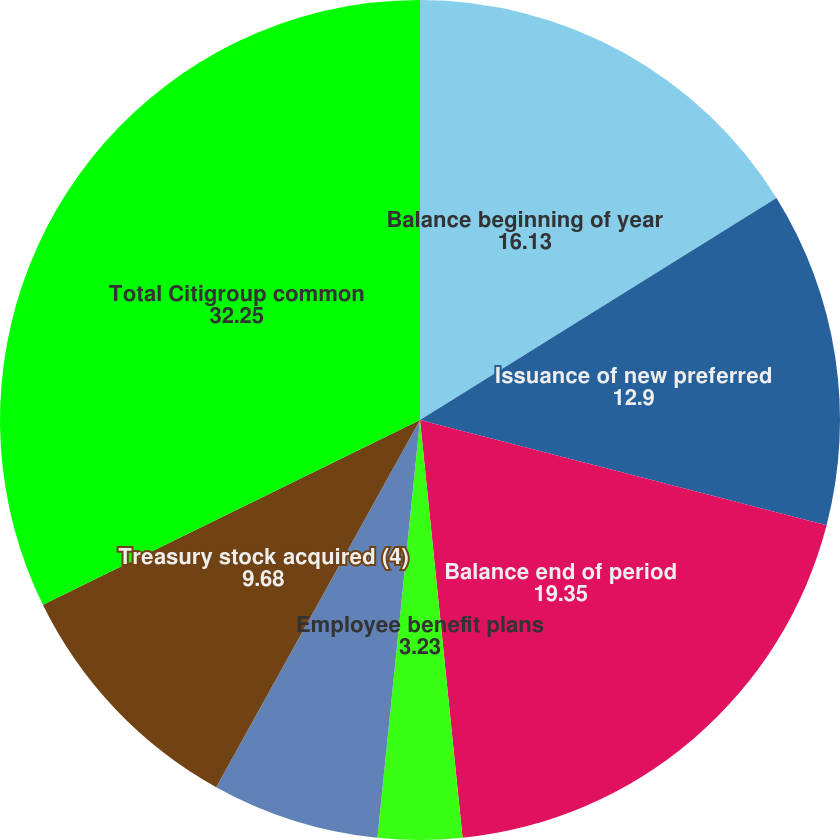<chart> <loc_0><loc_0><loc_500><loc_500><pie_chart><fcel>Balance beginning of year<fcel>Issuance of new preferred<fcel>Balance end of period<fcel>Employee benefit plans<fcel>Other<fcel>Employee benefit plans (3)<fcel>Treasury stock acquired (4)<fcel>Total Citigroup common<nl><fcel>16.13%<fcel>12.9%<fcel>19.35%<fcel>3.23%<fcel>0.0%<fcel>6.45%<fcel>9.68%<fcel>32.25%<nl></chart> 